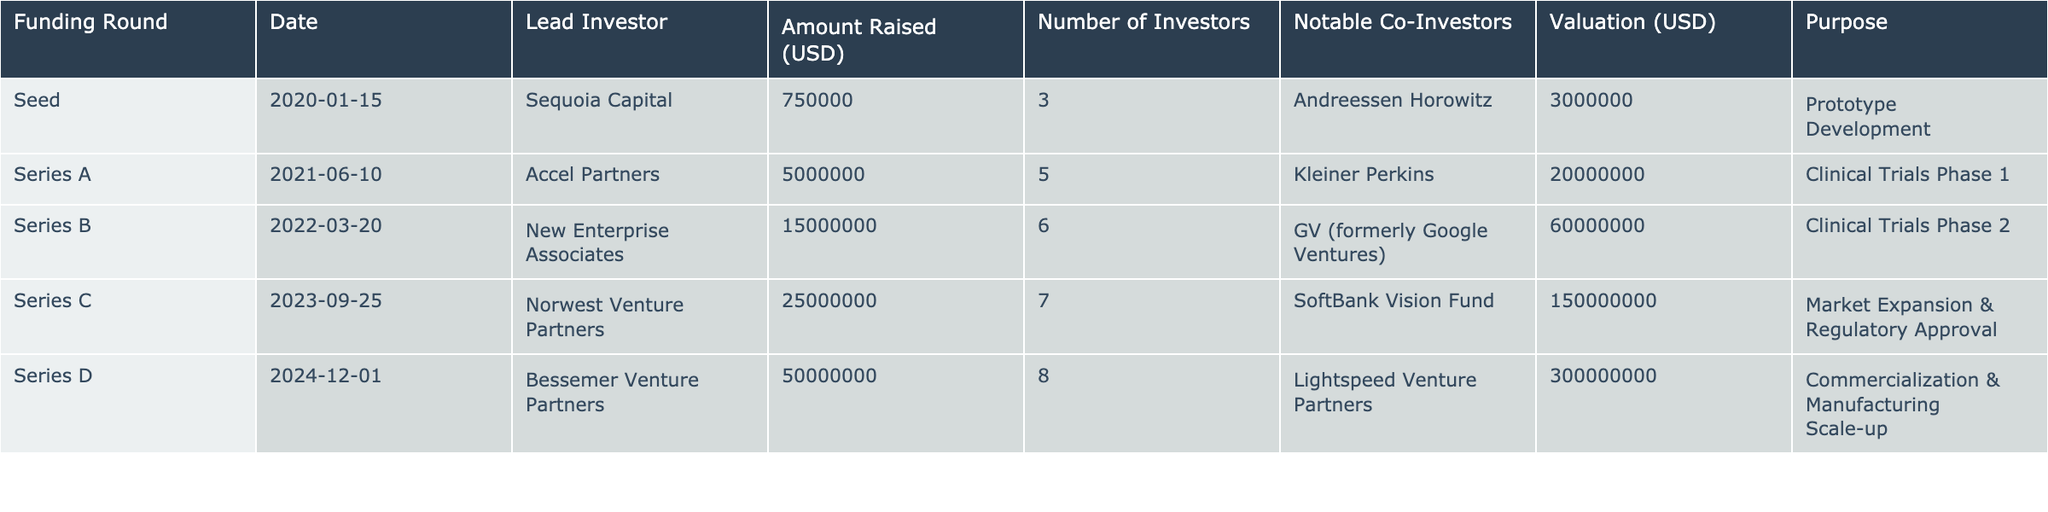What is the total amount raised in the Series C funding round? From the table, we can see that the amount raised in the Series C round is listed as 25000000 USD. This is a direct retrieval of data from the relevant row of the table.
Answer: 25000000 USD Which funding round had the highest valuation? By examining the valuation column, the Series D funding round shows a valuation of 300000000 USD, which is greater than any other listed valuation in the table. Hence, it is the highest.
Answer: Series D How many total investors participated across all funding rounds? The total number of investors can be calculated by summing up the "Number of Investors" column: 3 (Seed) + 5 (Series A) + 6 (Series B) + 7 (Series C) + 8 (Series D) = 29.
Answer: 29 Is there a notable co-investor for the Seed funding round? Looking at the Seed funding row, it shows "Andreessen Horowitz" listed as a notable co-investor. Since it is mentioned, the answer is yes.
Answer: Yes What was the average amount raised per funding round? To find the average, sum all amounts raised: 750000 + 5000000 + 15000000 + 25000000 + 50000000 = 95000000. Then divide by the number of funding rounds (5): 95000000 / 5 = 19000000.
Answer: 19000000 USD What is the difference in amount raised between Series B and Series D? The amount raised for Series B is 15000000 USD, and for Series D is 50000000 USD. The difference is calculated as 50000000 - 15000000 = 35000000 USD.
Answer: 35000000 USD Did any funding round specifically mention a purpose related to regulatory approval? In the table, Series C funding round mentions "Market Expansion & Regulatory Approval" as its purpose, making it true that at least one round has a regulatory approval purpose.
Answer: Yes Which lead investor was involved in the second funding round, and what was the amount raised? For Series A, the lead investor listed is "Accel Partners" and the amount raised is 5000000 USD. This is directly found by checking the relevant row.
Answer: Accel Partners, 5000000 USD What was the overall purpose of the funding in Series D? In the table, Series D states its purpose as "Commercialization & Manufacturing Scale-up," which specifies the intent for that funding round.
Answer: Commercialization & Manufacturing Scale-up 